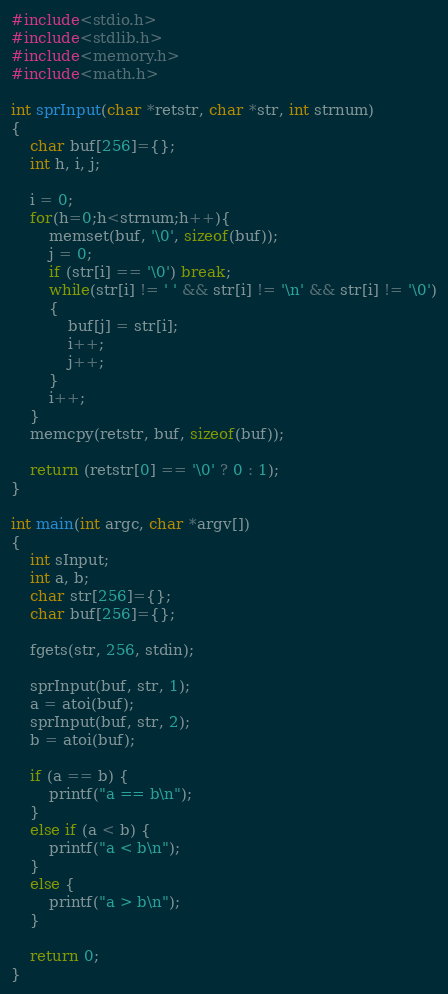<code> <loc_0><loc_0><loc_500><loc_500><_C_>#include<stdio.h>
#include<stdlib.h>
#include<memory.h>
#include<math.h>

int sprInput(char *retstr, char *str, int strnum)
{
	char buf[256]={};
	int h, i, j;

	i = 0;
	for(h=0;h<strnum;h++){
		memset(buf, '\0', sizeof(buf));
		j = 0;
		if (str[i] == '\0') break;
		while(str[i] != ' ' && str[i] != '\n' && str[i] != '\0')
		{
			buf[j] = str[i];
			i++;
			j++;
		}
		i++;
	}
	memcpy(retstr, buf, sizeof(buf));

	return (retstr[0] == '\0' ? 0 : 1);
}

int main(int argc, char *argv[])
{
	int sInput;
	int a, b;
	char str[256]={};
	char buf[256]={};

	fgets(str, 256, stdin);

	sprInput(buf, str, 1);
	a = atoi(buf);
	sprInput(buf, str, 2);
	b = atoi(buf);

	if (a == b) {
		printf("a == b\n");
	}
	else if (a < b) {
		printf("a < b\n");
	}
	else {
		printf("a > b\n");
	}

	return 0;
}</code> 